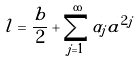Convert formula to latex. <formula><loc_0><loc_0><loc_500><loc_500>l = \frac { b } { 2 } + \sum _ { j = 1 } ^ { \infty } \alpha _ { j } a ^ { 2 j }</formula> 